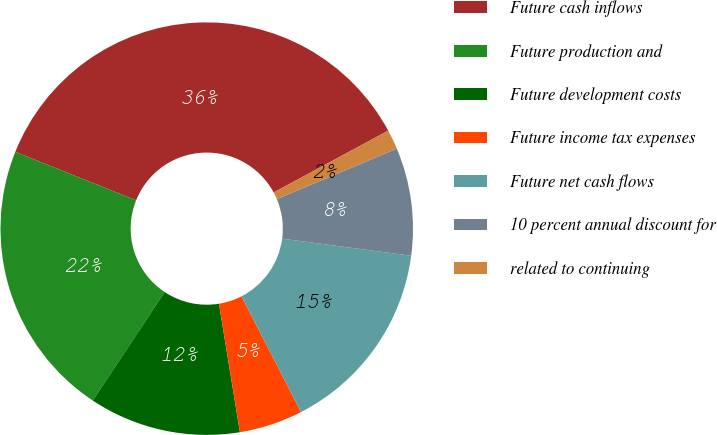<chart> <loc_0><loc_0><loc_500><loc_500><pie_chart><fcel>Future cash inflows<fcel>Future production and<fcel>Future development costs<fcel>Future income tax expenses<fcel>Future net cash flows<fcel>10 percent annual discount for<fcel>related to continuing<nl><fcel>36.05%<fcel>21.75%<fcel>11.89%<fcel>4.99%<fcel>15.34%<fcel>8.44%<fcel>1.54%<nl></chart> 